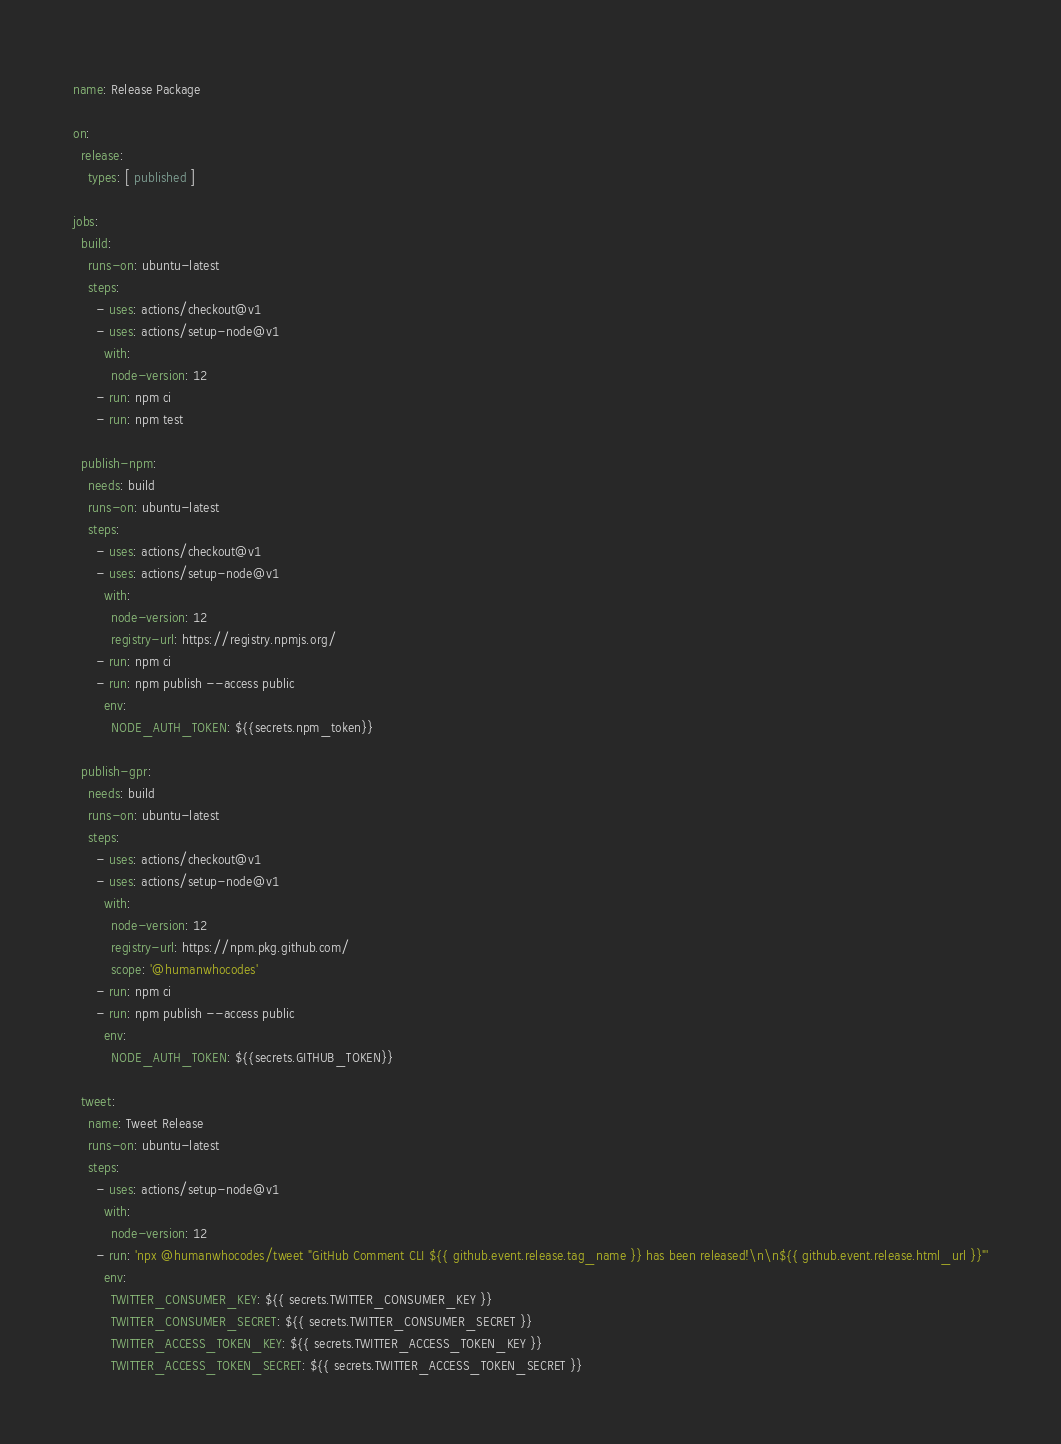Convert code to text. <code><loc_0><loc_0><loc_500><loc_500><_YAML_>name: Release Package

on:
  release:
    types: [ published ]

jobs:
  build:
    runs-on: ubuntu-latest
    steps:
      - uses: actions/checkout@v1
      - uses: actions/setup-node@v1
        with:
          node-version: 12
      - run: npm ci
      - run: npm test

  publish-npm:
    needs: build
    runs-on: ubuntu-latest
    steps:
      - uses: actions/checkout@v1
      - uses: actions/setup-node@v1
        with:
          node-version: 12
          registry-url: https://registry.npmjs.org/
      - run: npm ci
      - run: npm publish --access public
        env:
          NODE_AUTH_TOKEN: ${{secrets.npm_token}}

  publish-gpr:
    needs: build
    runs-on: ubuntu-latest
    steps:
      - uses: actions/checkout@v1
      - uses: actions/setup-node@v1
        with:
          node-version: 12
          registry-url: https://npm.pkg.github.com/
          scope: '@humanwhocodes'
      - run: npm ci
      - run: npm publish --access public
        env:
          NODE_AUTH_TOKEN: ${{secrets.GITHUB_TOKEN}}

  tweet:
    name: Tweet Release
    runs-on: ubuntu-latest
    steps:
      - uses: actions/setup-node@v1
        with:
          node-version: 12
      - run: 'npx @humanwhocodes/tweet "GitHub Comment CLI ${{ github.event.release.tag_name }} has been released!\n\n${{ github.event.release.html_url }}"'
        env:
          TWITTER_CONSUMER_KEY: ${{ secrets.TWITTER_CONSUMER_KEY }}
          TWITTER_CONSUMER_SECRET: ${{ secrets.TWITTER_CONSUMER_SECRET }}
          TWITTER_ACCESS_TOKEN_KEY: ${{ secrets.TWITTER_ACCESS_TOKEN_KEY }}
          TWITTER_ACCESS_TOKEN_SECRET: ${{ secrets.TWITTER_ACCESS_TOKEN_SECRET }}
</code> 